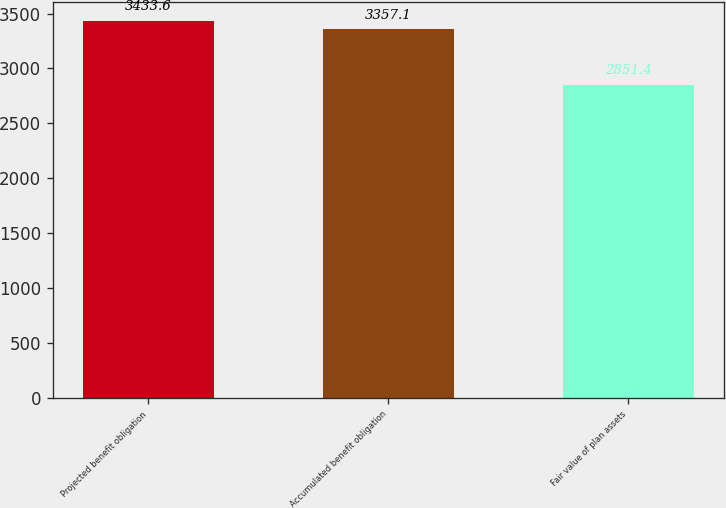Convert chart to OTSL. <chart><loc_0><loc_0><loc_500><loc_500><bar_chart><fcel>Projected benefit obligation<fcel>Accumulated benefit obligation<fcel>Fair value of plan assets<nl><fcel>3433.6<fcel>3357.1<fcel>2851.4<nl></chart> 